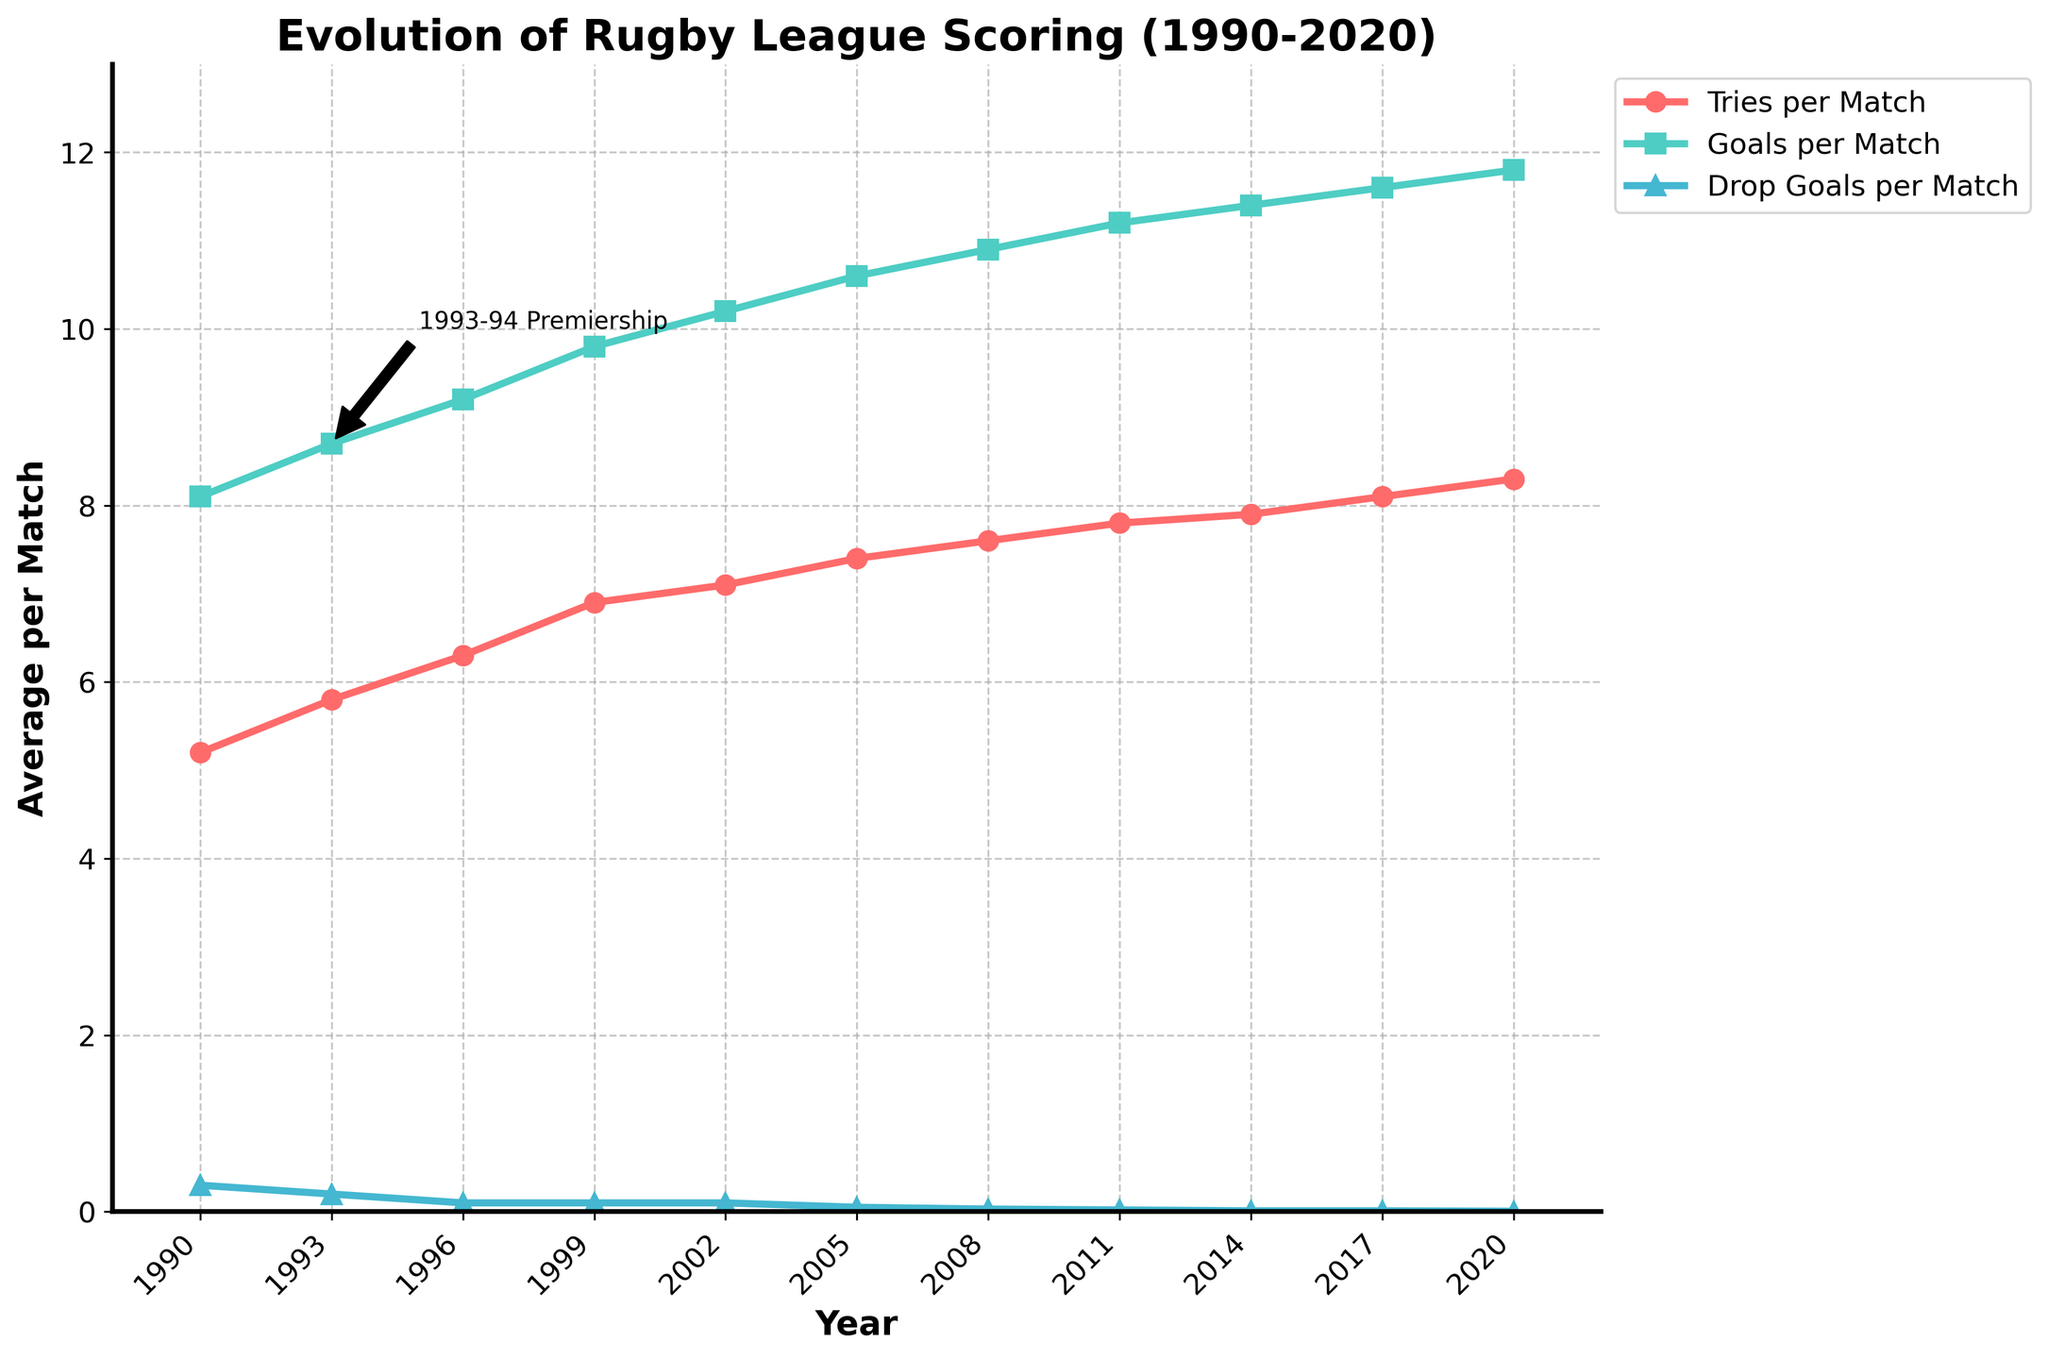How did the average number of tries per match change from 1990 to 2020? To find the change, we subtract the number of tries per match in 1990 from the number in 2020. The values are 8.3 (2020) and 5.2 (1990), so 8.3 - 5.2 = 3.1.
Answer: 3.1 Which year had the highest average number of goals per match? By examining the plot, the highest average number of goals per match occurs in 2020, where it reaches 11.8.
Answer: 2020 Compare the trend of drop goals per match to the trend of tries per match between 1990 and 2020. Tries per match have generally increased over the years, from 5.2 in 1990 to 8.3 in 2020. In contrast, drop goals per match have decreased from 0.3 in 1990 to 0.005 in 2020.
Answer: Tries increased, drop goals decreased What is the average number of tries per match during the 1990s (1990-1999)? To find the average, sum the tries per match for the years 1990, 1993, 1996, and 1999, then divide by the number of years. The values are 5.2, 5.8, 6.3, and 6.9, so the average is (5.2 + 5.8 + 6.3 + 6.9) / 4 = 6.05.
Answer: 6.05 By how much did the goals per match increase from the 1993-94 Premiership to the year 2020? The value during the 1993-94 Premiership is 8.7 in 1993, and in 2020 it is 11.8. The difference is 11.8 - 8.7 = 3.1.
Answer: 3.1 In which year did the drop goals per match fall below 0.1? By checking the plot, drop goals per match fell below 0.1 for the first time in 2005 where the value was 0.05.
Answer: 2005 What linear trend can be observed in goals per match from 1990 to 2020? The overall trend for goals per match is increasing. Starting at 8.1 in 1990 and rising to 11.8 in 2020, indicating a gradual increase over the years.
Answer: Increasing Compare the rate of increase between tries per match and goals per match from 1990 to 2020. Both tries and goals per match show an increasing trend. However, the increase in tries per match (from 5.2 to 8.3) is less steep compared to the increase in goals per match (from 8.1 to 11.8).
Answer: Goals increased faster than tries 